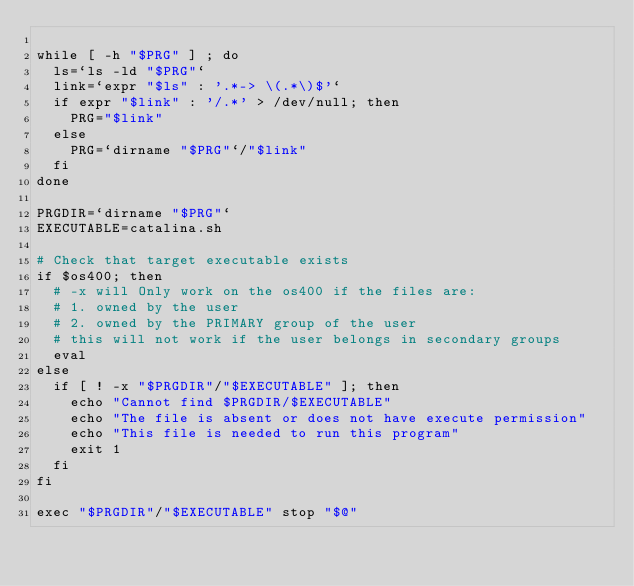<code> <loc_0><loc_0><loc_500><loc_500><_Bash_>
while [ -h "$PRG" ] ; do
  ls=`ls -ld "$PRG"`
  link=`expr "$ls" : '.*-> \(.*\)$'`
  if expr "$link" : '/.*' > /dev/null; then
    PRG="$link"
  else
    PRG=`dirname "$PRG"`/"$link"
  fi
done

PRGDIR=`dirname "$PRG"`
EXECUTABLE=catalina.sh

# Check that target executable exists
if $os400; then
  # -x will Only work on the os400 if the files are:
  # 1. owned by the user
  # 2. owned by the PRIMARY group of the user
  # this will not work if the user belongs in secondary groups
  eval
else
  if [ ! -x "$PRGDIR"/"$EXECUTABLE" ]; then
    echo "Cannot find $PRGDIR/$EXECUTABLE"
    echo "The file is absent or does not have execute permission"
    echo "This file is needed to run this program"
    exit 1
  fi
fi

exec "$PRGDIR"/"$EXECUTABLE" stop "$@"
</code> 